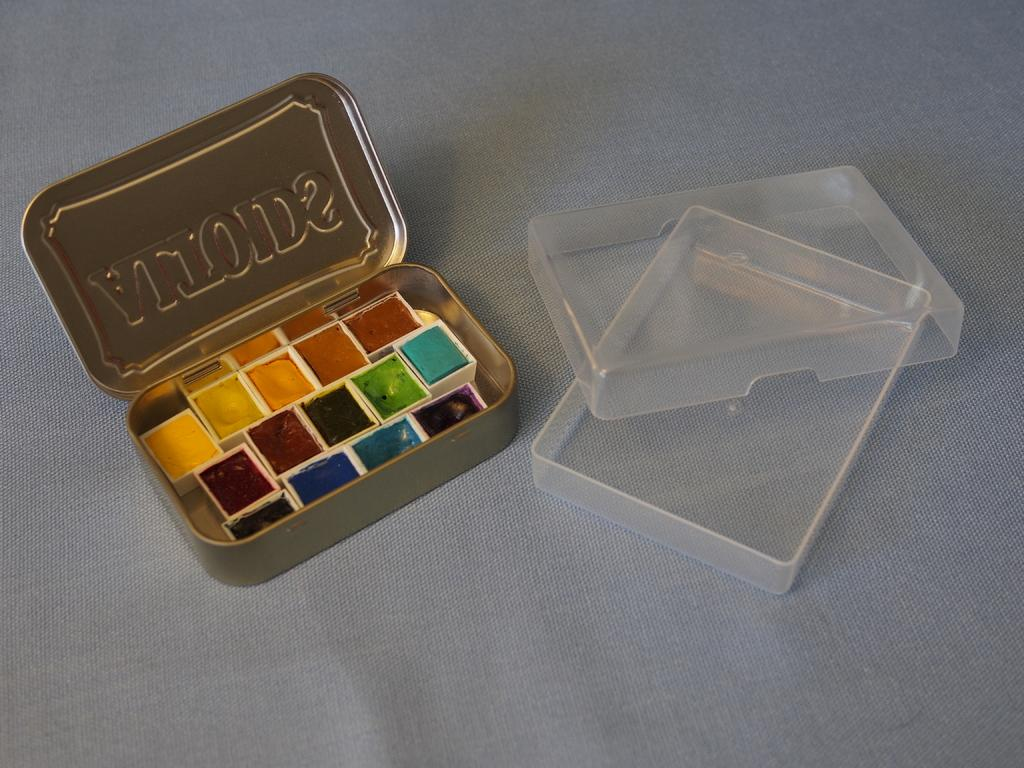<image>
Give a short and clear explanation of the subsequent image. A can of altoids opened up with paint inside 